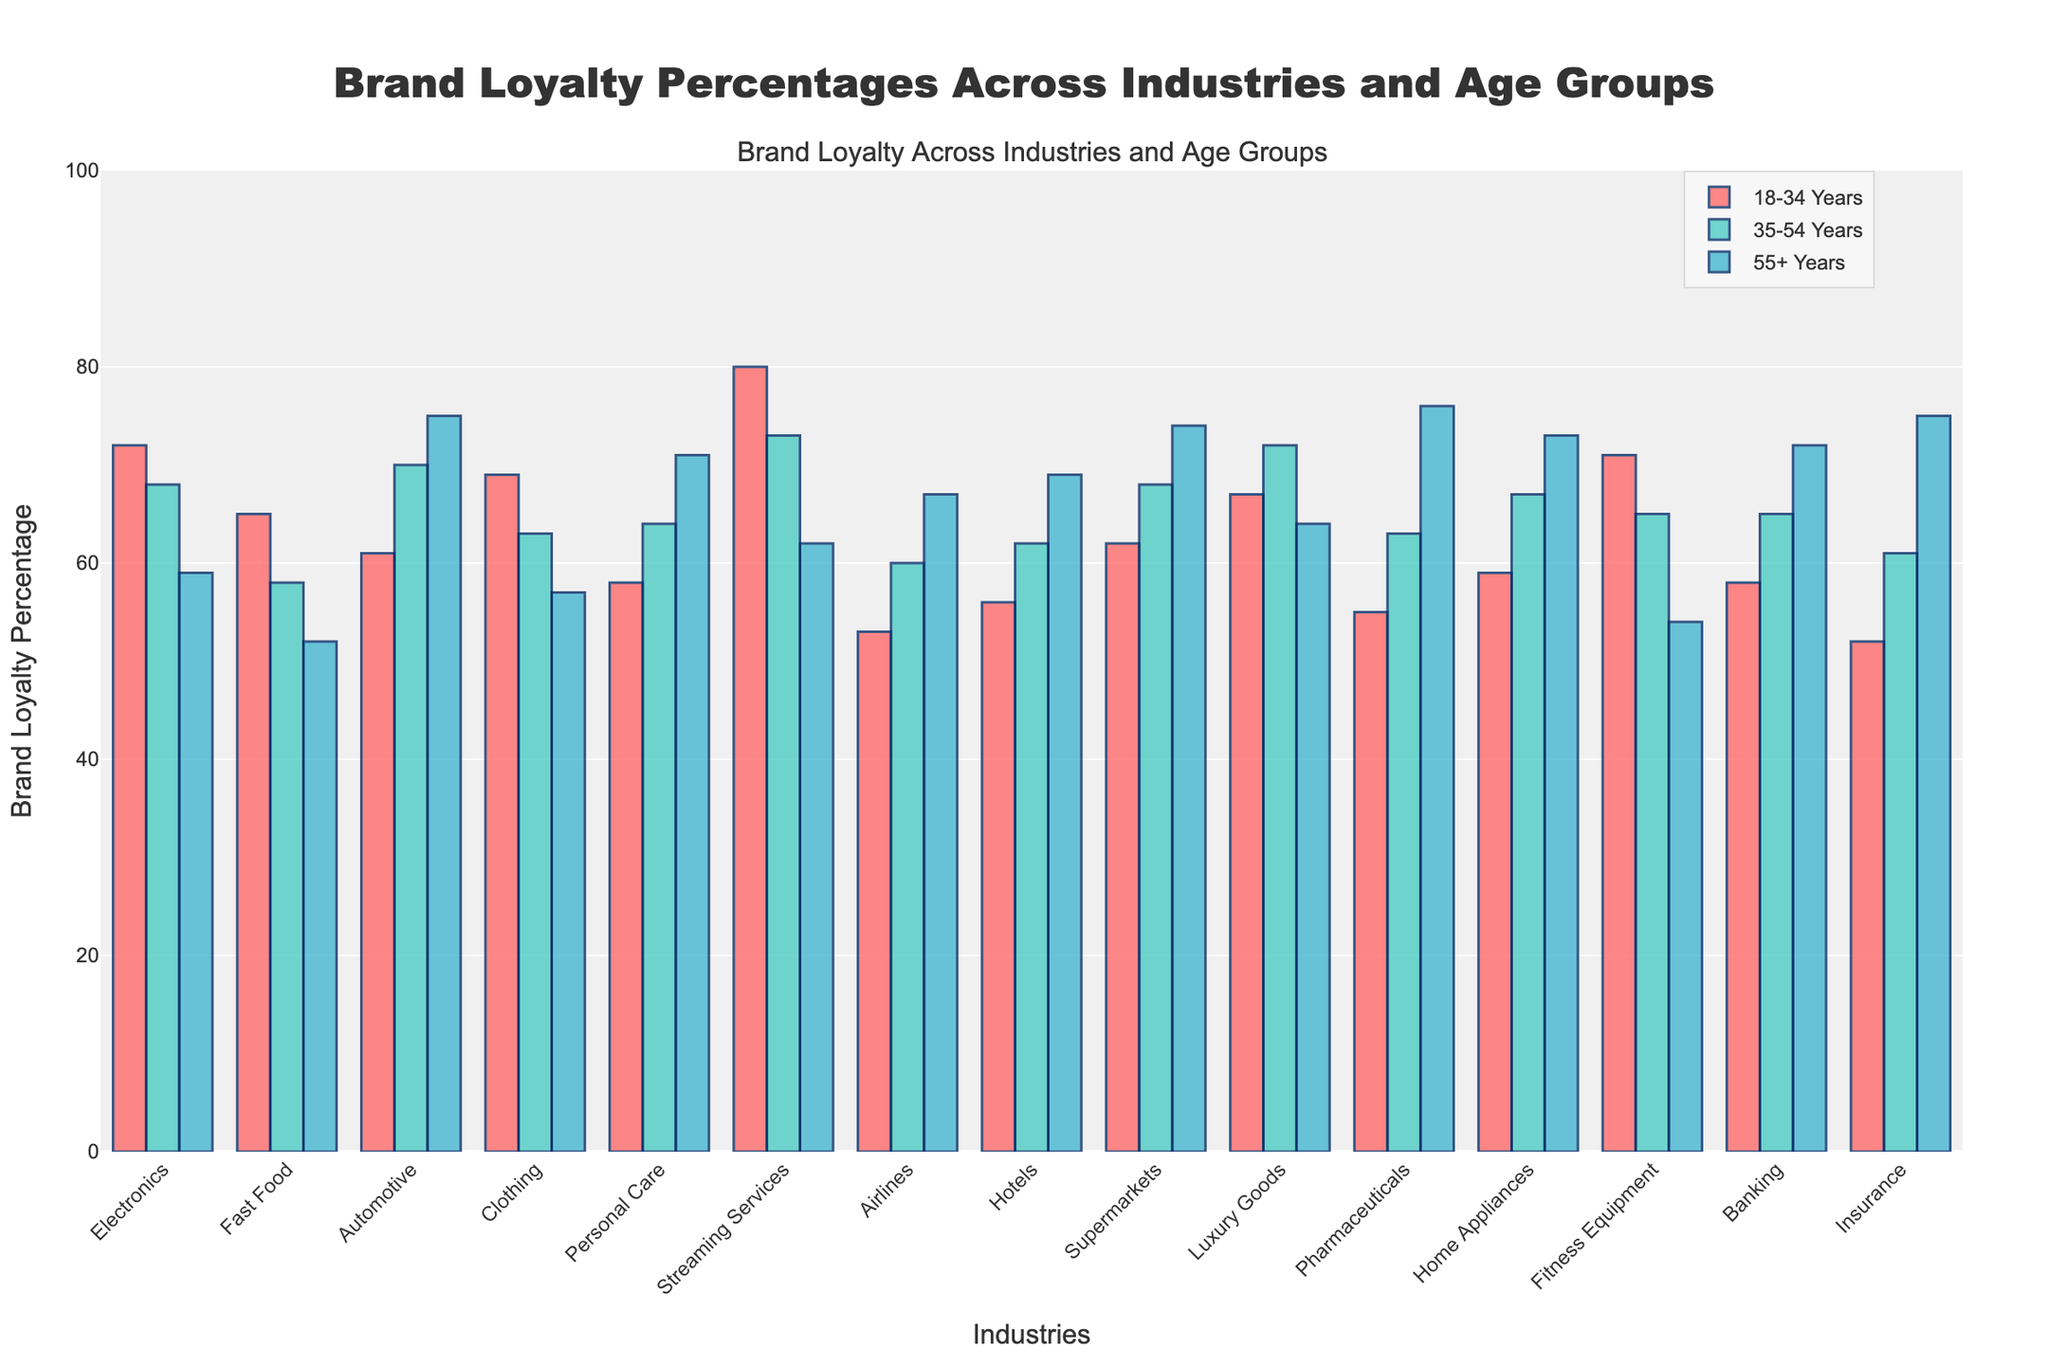Which age group shows the highest brand loyalty for Personal Care products? The bars corresponding to the "55+ Years" age group should be checked to find the highest percentage for Personal Care products. The "55+ Years" has the highest brand loyalty at 71%.
Answer: "55+ Years" In which industry do the "18-34 Years" and "35-54 Years" age groups have the most similar brand loyalty percentages? By visually comparing the heights of the bars for "18-34 Years" and "35-54 Years" age groups across all industries, we see that "Fast Food" shows very close percentages: 65% for "18-34 Years" and 58% for "35-54 Years".
Answer: Fast Food What is the average brand loyalty percentage for the "55+ Years" age group across all industries? First, sum the brand loyalty percentages of the "55+ Years" age group across all industries and then divide by the number of industries. The calculation is (59 + 52 + 75 + 57 + 71 + 62 + 67 + 69 + 74 + 64 + 76 + 73 + 54 + 72 + 75) / 15 = 67.27%
Answer: 67.27% Which industry has the largest difference in brand loyalty between the "18-34 Years" and "55+ Years" age groups? Calculate the differences in brand loyalty percentages between the "18-34 Years" and "55+ Years" age groups for each industry, then identify the largest difference. The largest difference is in Fitness Equipment (71% - 54% = 17%).
Answer: Fitness Equipment How does the brand loyalty of the "35-54 Years" age group in the Electronics industry compare to that in the Automotive industry? By comparing the bar heights for the Electronics industry (68%) and Automotive industry (70%) for the "35-54 Years" age group, we see that Automotive is higher by 2%.
Answer: Automotive is 2% higher Which industry shows the lowest brand loyalty percentage for the "18-34 Years" age group? Check the bars for "18-34 Years" age group across all industries and identify the shortest bar. The Airlines industry has the lowest at 53%.
Answer: Airlines What is the median brand loyalty percentage for the "35-54 Years" age group across all industries? List out all brand loyalty percentages for the "35-54 Years" age group, sort them, and find the middle value. Sorted values: 58, 60, 61, 62, 63, 63, 64, 65, 65, 67, 68, 68, 70, 72, 73. The median is 65%.
Answer: 65% In which industry do all age groups show brand loyalty percentages under 60%? Check the heights of bars for each age group in each industry to ensure they are all below 60%. Only the Fast Food industry meets this criterion.
Answer: Fast Food What is the combined brand loyalty percentage of the "18-34 Years" group for Clothing, Luxury Goods, and Pharmaceuticals? Sum the brand loyalty percentages of the "18-34 Years" group for these three industries: 69% (Clothing) + 67% (Luxury Goods) + 55% (Pharmaceuticals) = 191%.
Answer: 191% 